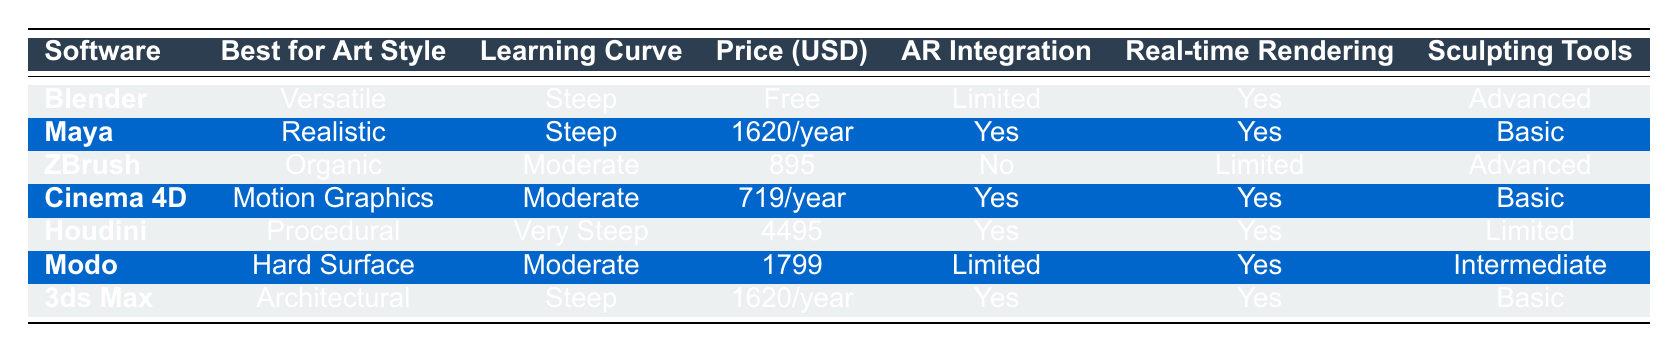What is the price of Blender? The price of Blender is listed in the table as "Free".
Answer: Free Which software has the steepest learning curve? The software with the steepest learning curve, according to the table, is Houdini, as it is categorized as "Very Steep".
Answer: Houdini How many software provide real-time rendering? The table shows that Blender, Maya, Cinema 4D, Houdini, Modo, and 3ds Max all provide real-time rendering, totaling 6 software.
Answer: 6 Is ZBrush best for realistic art style? No, ZBrush is best for "Organic" art style, not realistic.
Answer: No Which software has basic sculpting tools and AR integration? The software that matches both criteria is Maya, as it has basic sculpting tools and confirms AR integration.
Answer: Maya What is the average price of the software that supports AR integration? The software that supports AR integration and their prices are Maya ($1620), Cinema 4D ($719), Houdini ($4495), 3ds Max ($1620). Average calculation: (1620 + 719 + 4495 + 1620) / 4 = 2263.5.
Answer: 2263.5 Which software is best for hard surface art style, and what are its sculpting tools? Modo is best for hard surface art style and has intermediate sculpting tools according to the table.
Answer: Modo, Intermediate What is the difference in price between Blender and Houdini? Blender is free while Houdini costs $4495. The difference in price is $4495 - $0 = $4495.
Answer: 4495 Which software is best for motion graphics and how much does it cost? Cinema 4D is best for motion graphics, and it costs $719 per year.
Answer: Cinema 4D, 719 Does ZBrush have real-time rendering? No, ZBrush is indicated in the table as having limited real-time rendering capabilities.
Answer: No What other software, besides Modo, is best for moderate learning curves? The other software with a moderate learning curve besides Modo is Cinema 4D and ZBrush.
Answer: Cinema 4D, ZBrush 